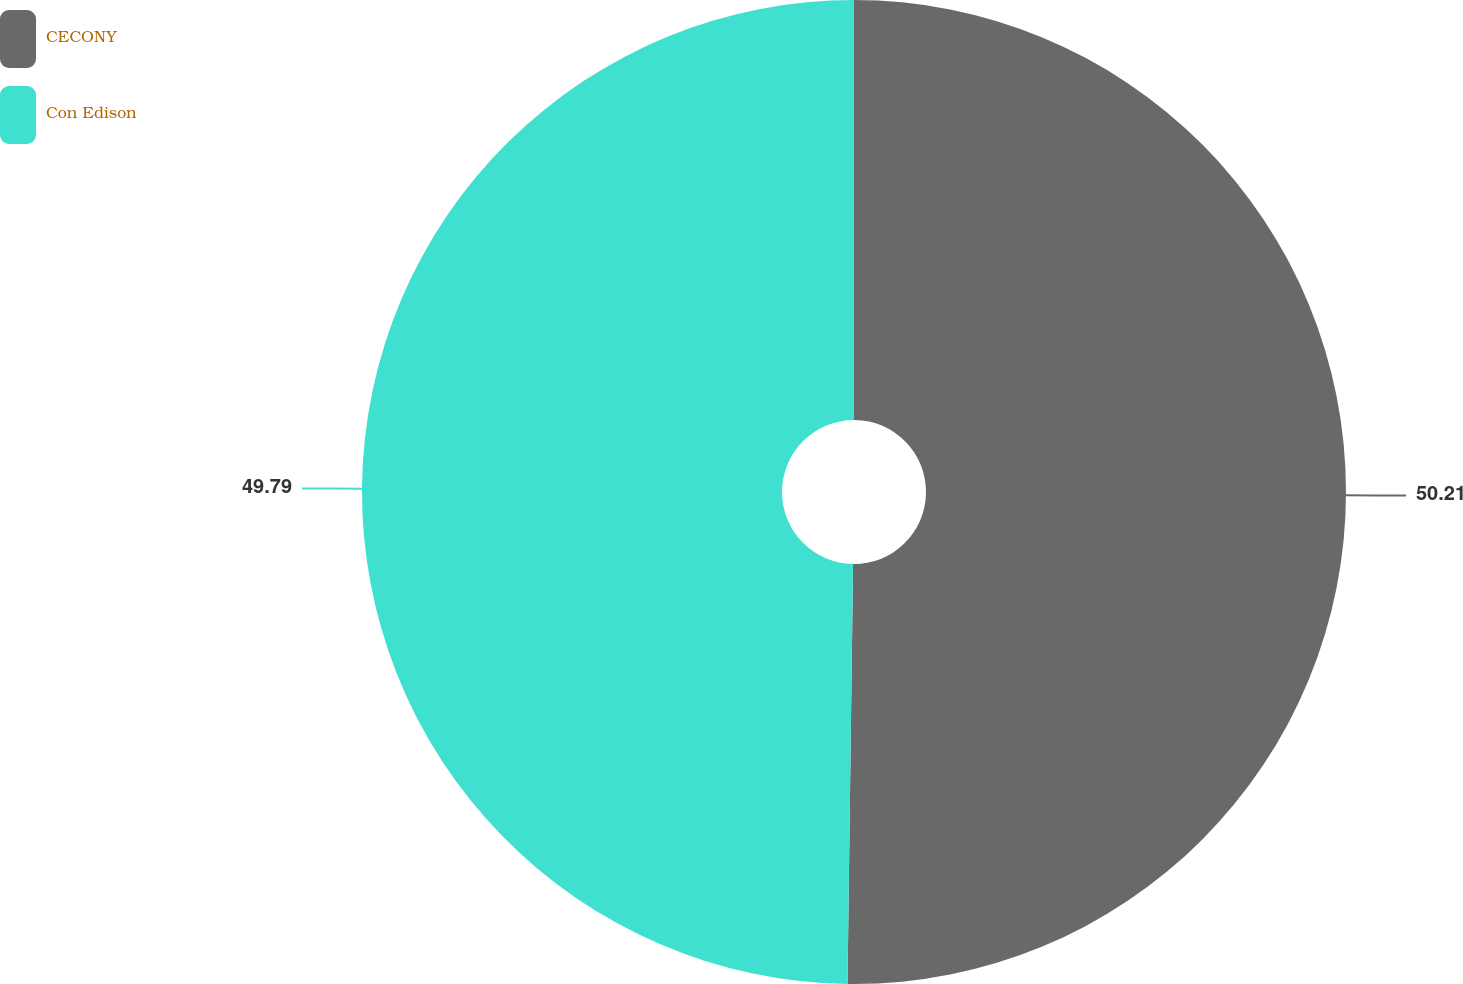Convert chart to OTSL. <chart><loc_0><loc_0><loc_500><loc_500><pie_chart><fcel>CECONY<fcel>Con Edison<nl><fcel>50.21%<fcel>49.79%<nl></chart> 